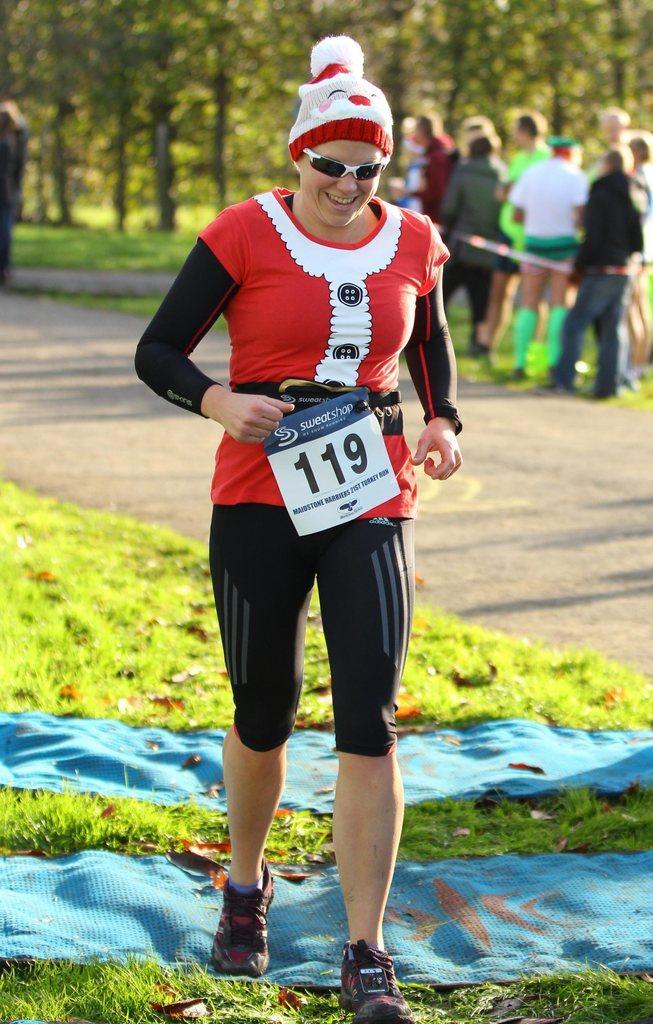How would you summarize this image in a sentence or two? In this image in the center there is one person who is running and she is wearing some costume, and at the bottom there is grass and some clothes and there are some dry leaves. In the background there are group of people standing, and there are trees and in the center there is a walkway. 